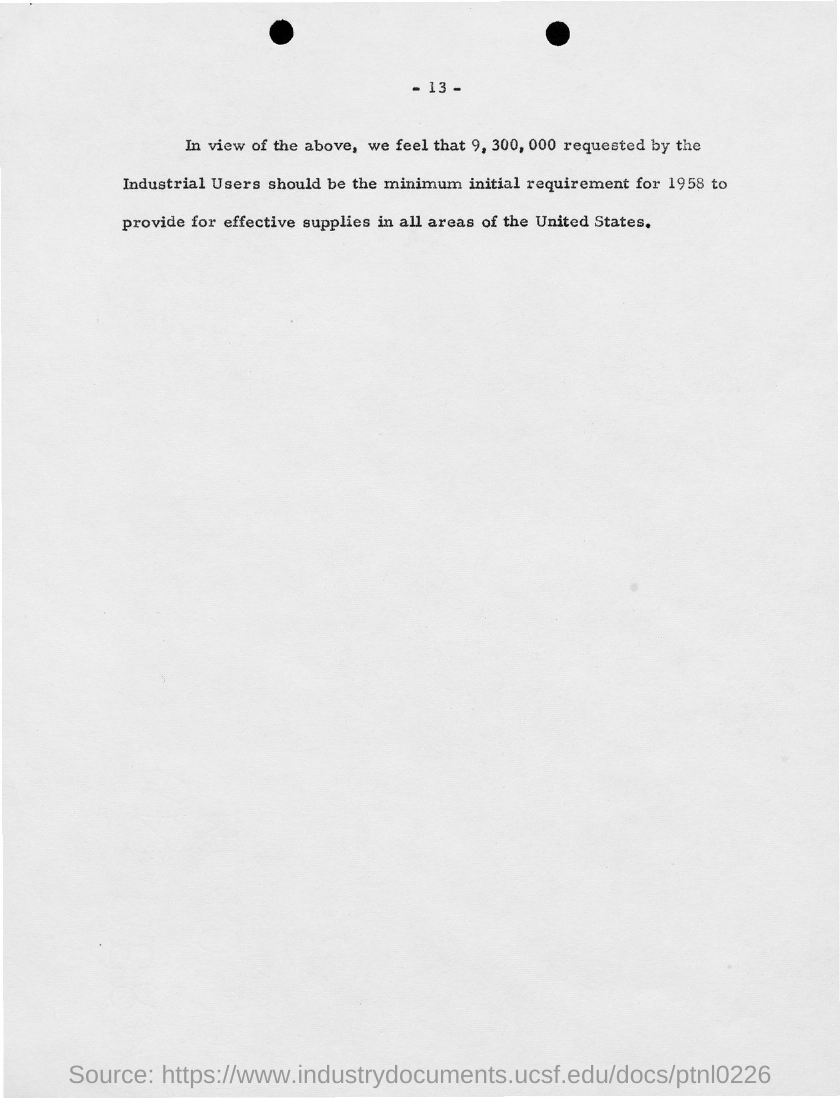List a handful of essential elements in this visual. The page number mentioned in this document is 13. 